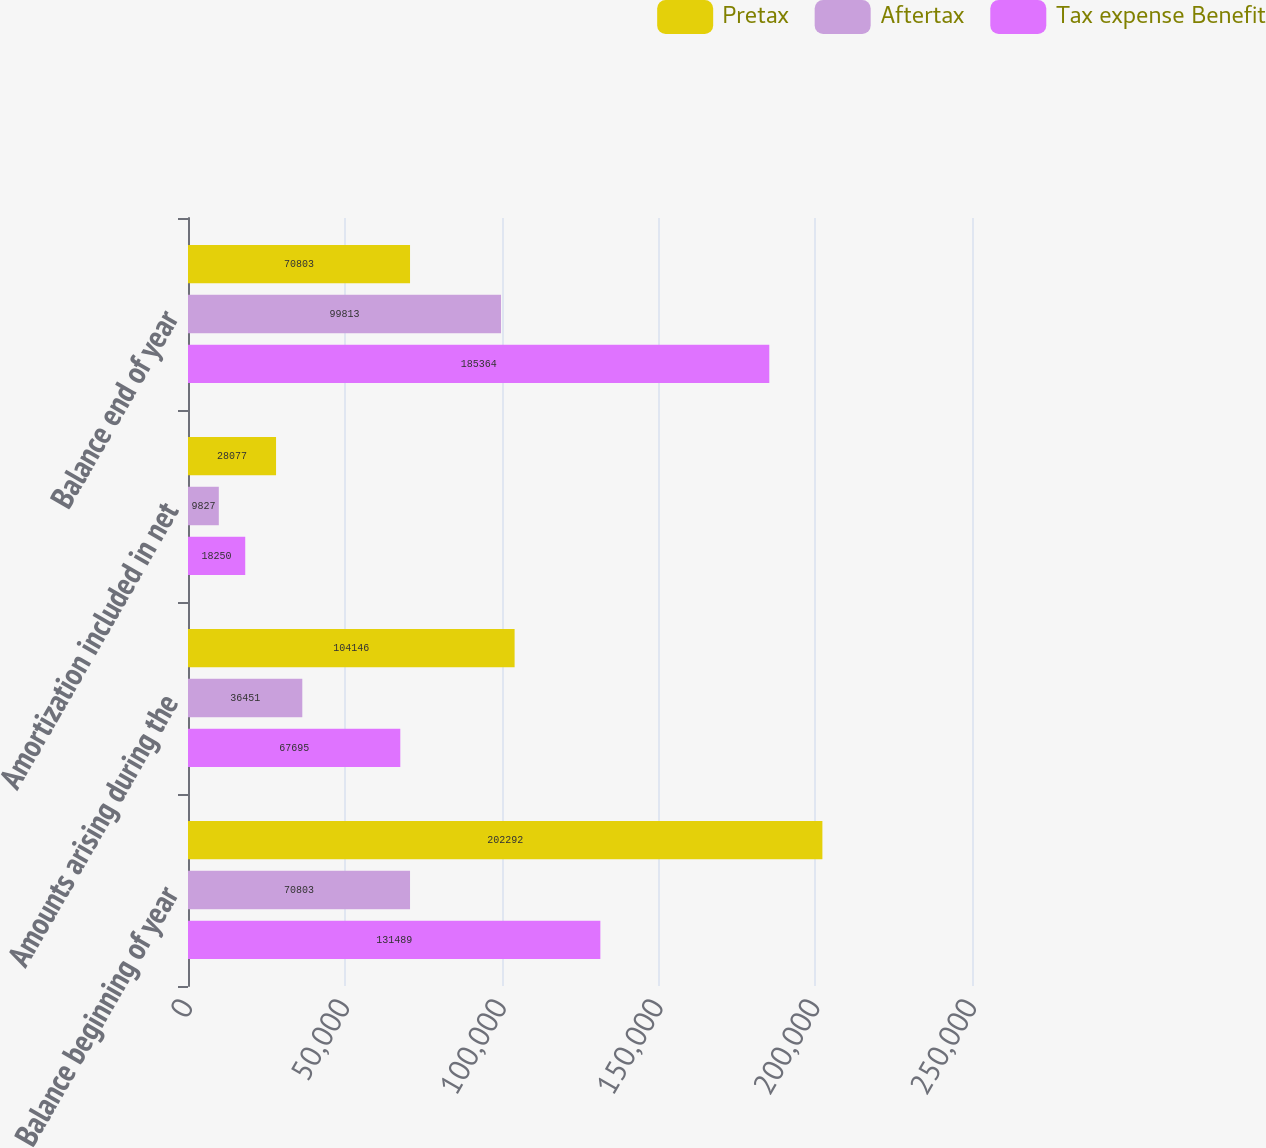Convert chart. <chart><loc_0><loc_0><loc_500><loc_500><stacked_bar_chart><ecel><fcel>Balance beginning of year<fcel>Amounts arising during the<fcel>Amortization included in net<fcel>Balance end of year<nl><fcel>Pretax<fcel>202292<fcel>104146<fcel>28077<fcel>70803<nl><fcel>Aftertax<fcel>70803<fcel>36451<fcel>9827<fcel>99813<nl><fcel>Tax expense Benefit<fcel>131489<fcel>67695<fcel>18250<fcel>185364<nl></chart> 